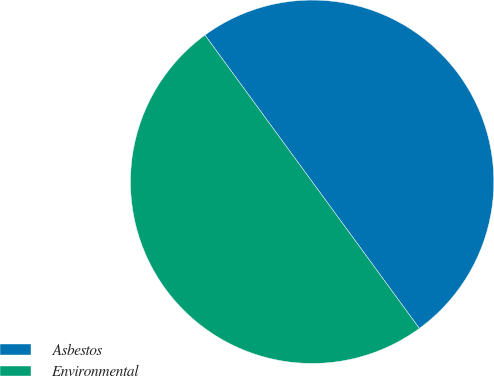<chart> <loc_0><loc_0><loc_500><loc_500><pie_chart><fcel>Asbestos<fcel>Environmental<nl><fcel>50.0%<fcel>50.0%<nl></chart> 